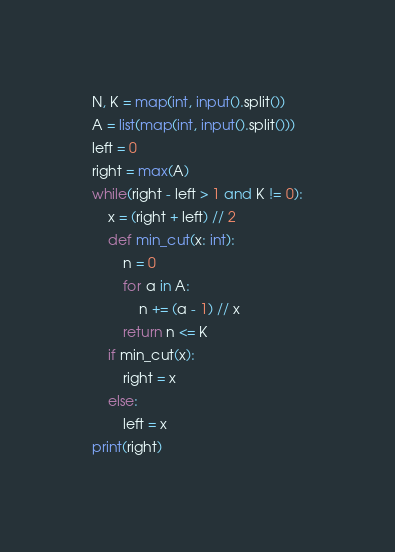<code> <loc_0><loc_0><loc_500><loc_500><_Python_>N, K = map(int, input().split())
A = list(map(int, input().split()))
left = 0
right = max(A)
while(right - left > 1 and K != 0):
    x = (right + left) // 2
    def min_cut(x: int):
        n = 0
        for a in A:
            n += (a - 1) // x
        return n <= K
    if min_cut(x):
        right = x
    else:
        left = x
print(right)</code> 